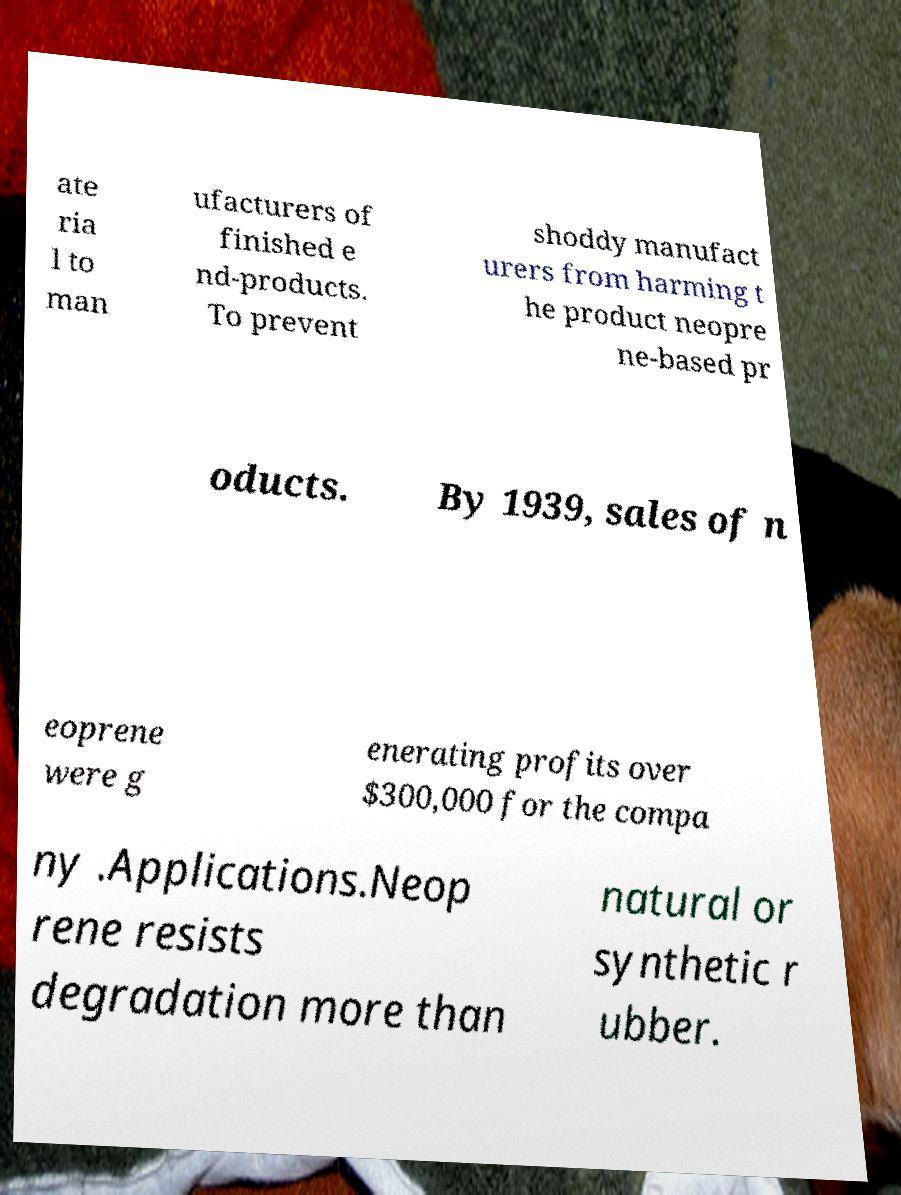What messages or text are displayed in this image? I need them in a readable, typed format. ate ria l to man ufacturers of finished e nd-products. To prevent shoddy manufact urers from harming t he product neopre ne-based pr oducts. By 1939, sales of n eoprene were g enerating profits over $300,000 for the compa ny .Applications.Neop rene resists degradation more than natural or synthetic r ubber. 